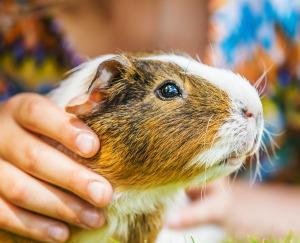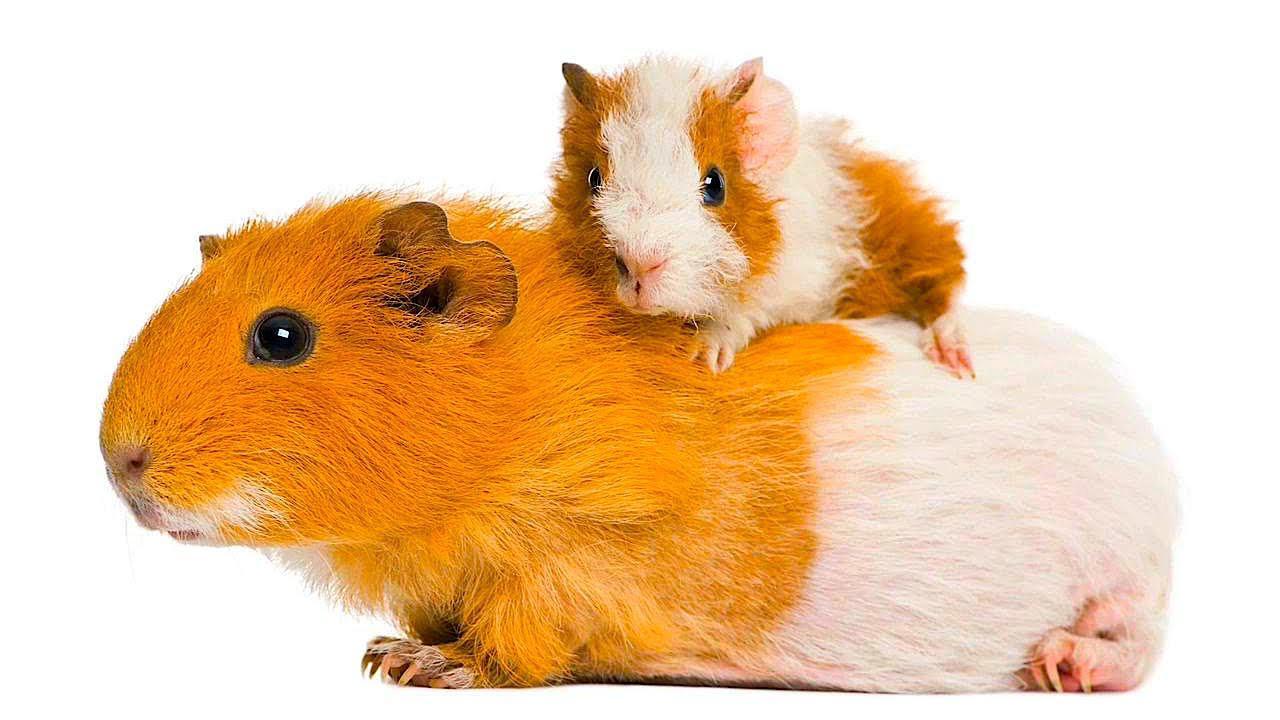The first image is the image on the left, the second image is the image on the right. Given the left and right images, does the statement "At least one image contains two guinea pigs." hold true? Answer yes or no. Yes. 